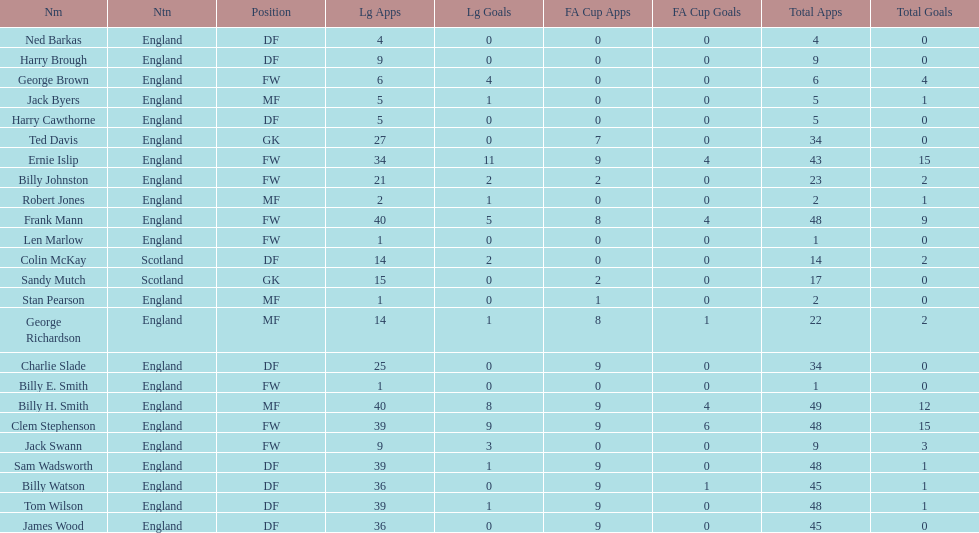What is the last name listed on this chart? James Wood. Help me parse the entirety of this table. {'header': ['Nm', 'Ntn', 'Position', 'Lg Apps', 'Lg Goals', 'FA Cup Apps', 'FA Cup Goals', 'Total Apps', 'Total Goals'], 'rows': [['Ned Barkas', 'England', 'DF', '4', '0', '0', '0', '4', '0'], ['Harry Brough', 'England', 'DF', '9', '0', '0', '0', '9', '0'], ['George Brown', 'England', 'FW', '6', '4', '0', '0', '6', '4'], ['Jack Byers', 'England', 'MF', '5', '1', '0', '0', '5', '1'], ['Harry Cawthorne', 'England', 'DF', '5', '0', '0', '0', '5', '0'], ['Ted Davis', 'England', 'GK', '27', '0', '7', '0', '34', '0'], ['Ernie Islip', 'England', 'FW', '34', '11', '9', '4', '43', '15'], ['Billy Johnston', 'England', 'FW', '21', '2', '2', '0', '23', '2'], ['Robert Jones', 'England', 'MF', '2', '1', '0', '0', '2', '1'], ['Frank Mann', 'England', 'FW', '40', '5', '8', '4', '48', '9'], ['Len Marlow', 'England', 'FW', '1', '0', '0', '0', '1', '0'], ['Colin McKay', 'Scotland', 'DF', '14', '2', '0', '0', '14', '2'], ['Sandy Mutch', 'Scotland', 'GK', '15', '0', '2', '0', '17', '0'], ['Stan Pearson', 'England', 'MF', '1', '0', '1', '0', '2', '0'], ['George Richardson', 'England', 'MF', '14', '1', '8', '1', '22', '2'], ['Charlie Slade', 'England', 'DF', '25', '0', '9', '0', '34', '0'], ['Billy E. Smith', 'England', 'FW', '1', '0', '0', '0', '1', '0'], ['Billy H. Smith', 'England', 'MF', '40', '8', '9', '4', '49', '12'], ['Clem Stephenson', 'England', 'FW', '39', '9', '9', '6', '48', '15'], ['Jack Swann', 'England', 'FW', '9', '3', '0', '0', '9', '3'], ['Sam Wadsworth', 'England', 'DF', '39', '1', '9', '0', '48', '1'], ['Billy Watson', 'England', 'DF', '36', '0', '9', '1', '45', '1'], ['Tom Wilson', 'England', 'DF', '39', '1', '9', '0', '48', '1'], ['James Wood', 'England', 'DF', '36', '0', '9', '0', '45', '0']]} 